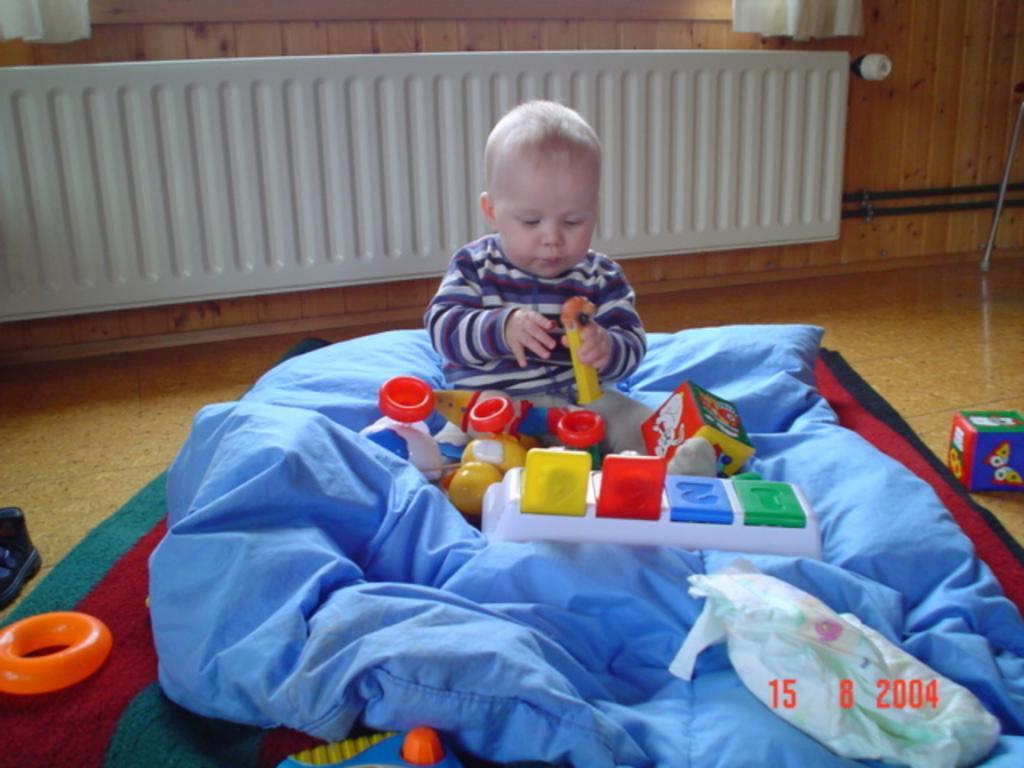Describe this image in one or two sentences. This picture is clicked inside the room. In the center we can see a kid wearing T-shirt, holding some toy and sitting and we can see the toys and some objects are lying on the ground. In the background we can see the wall, curtains and some other items. 